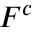Convert formula to latex. <formula><loc_0><loc_0><loc_500><loc_500>F ^ { c }</formula> 